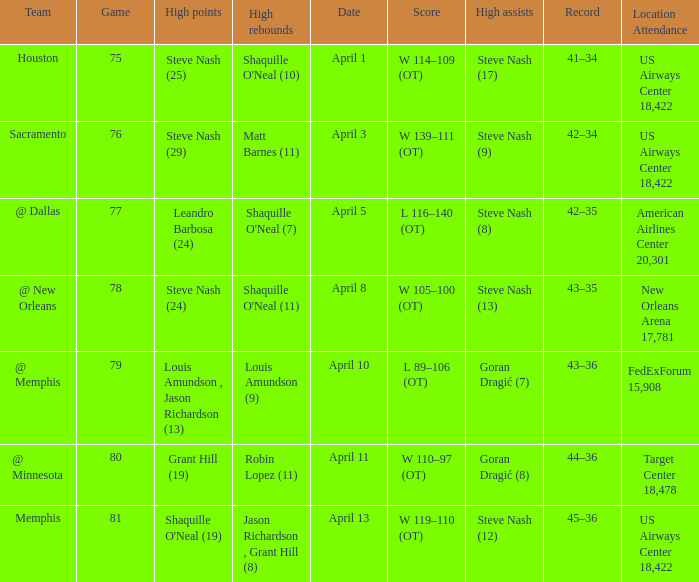Who did the most assists when Matt Barnes (11) got the most rebounds? Steve Nash (9). 